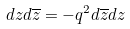Convert formula to latex. <formula><loc_0><loc_0><loc_500><loc_500>d z d \overline { z } = - q ^ { 2 } d \overline { z } d z</formula> 